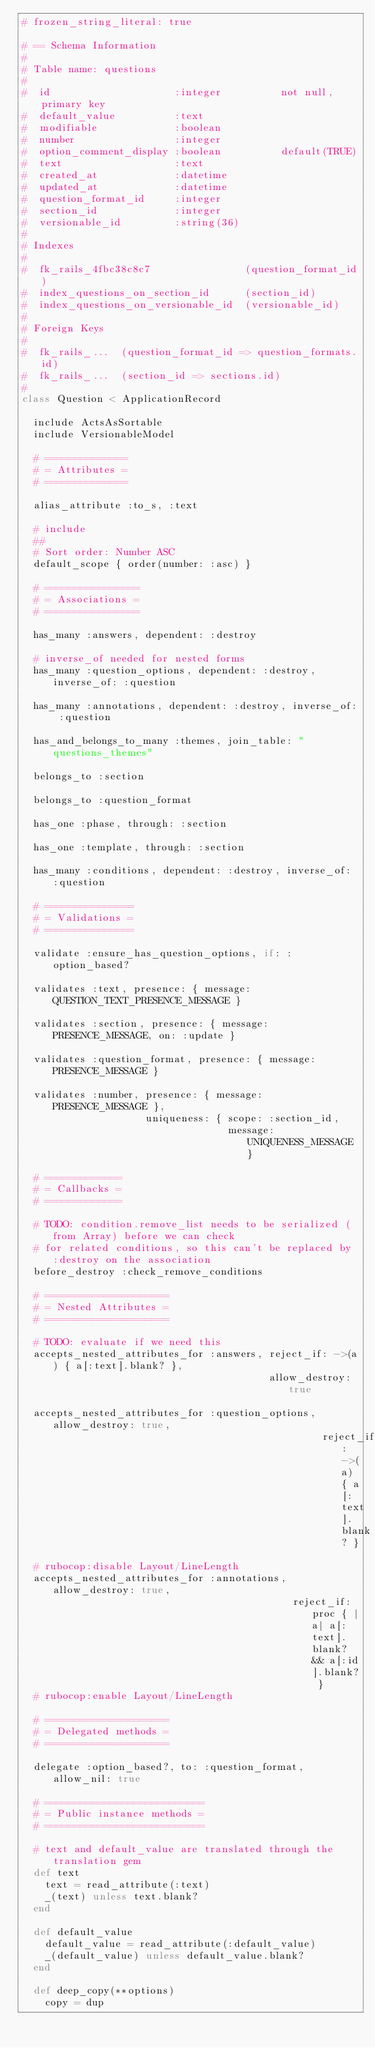Convert code to text. <code><loc_0><loc_0><loc_500><loc_500><_Ruby_># frozen_string_literal: true

# == Schema Information
#
# Table name: questions
#
#  id                     :integer          not null, primary key
#  default_value          :text
#  modifiable             :boolean
#  number                 :integer
#  option_comment_display :boolean          default(TRUE)
#  text                   :text
#  created_at             :datetime
#  updated_at             :datetime
#  question_format_id     :integer
#  section_id             :integer
#  versionable_id         :string(36)
#
# Indexes
#
#  fk_rails_4fbc38c8c7                (question_format_id)
#  index_questions_on_section_id      (section_id)
#  index_questions_on_versionable_id  (versionable_id)
#
# Foreign Keys
#
#  fk_rails_...  (question_format_id => question_formats.id)
#  fk_rails_...  (section_id => sections.id)
#
class Question < ApplicationRecord

  include ActsAsSortable
  include VersionableModel

  # ==============
  # = Attributes =
  # ==============

  alias_attribute :to_s, :text

  # include
  ##
  # Sort order: Number ASC
  default_scope { order(number: :asc) }

  # ================
  # = Associations =
  # ================

  has_many :answers, dependent: :destroy

  # inverse_of needed for nested forms
  has_many :question_options, dependent: :destroy, inverse_of: :question

  has_many :annotations, dependent: :destroy, inverse_of: :question

  has_and_belongs_to_many :themes, join_table: "questions_themes"

  belongs_to :section

  belongs_to :question_format

  has_one :phase, through: :section

  has_one :template, through: :section

  has_many :conditions, dependent: :destroy, inverse_of: :question

  # ===============
  # = Validations =
  # ===============

  validate :ensure_has_question_options, if: :option_based?

  validates :text, presence: { message: QUESTION_TEXT_PRESENCE_MESSAGE }

  validates :section, presence: { message: PRESENCE_MESSAGE, on: :update }

  validates :question_format, presence: { message: PRESENCE_MESSAGE }

  validates :number, presence: { message: PRESENCE_MESSAGE },
                     uniqueness: { scope: :section_id,
                                   message: UNIQUENESS_MESSAGE }

  # =============
  # = Callbacks =
  # =============

  # TODO: condition.remove_list needs to be serialized (from Array) before we can check
  # for related conditions, so this can't be replaced by :destroy on the association
  before_destroy :check_remove_conditions

  # =====================
  # = Nested Attributes =
  # =====================

  # TODO: evaluate if we need this
  accepts_nested_attributes_for :answers, reject_if: ->(a) { a[:text].blank? },
                                          allow_destroy: true

  accepts_nested_attributes_for :question_options, allow_destroy: true,
                                                   reject_if: ->(a) { a[:text].blank? }

  # rubocop:disable Layout/LineLength
  accepts_nested_attributes_for :annotations, allow_destroy: true,
                                              reject_if: proc { |a| a[:text].blank? && a[:id].blank? }
  # rubocop:enable Layout/LineLength

  # =====================
  # = Delegated methods =
  # =====================

  delegate :option_based?, to: :question_format, allow_nil: true

  # ===========================
  # = Public instance methods =
  # ===========================

  # text and default_value are translated through the translation gem
  def text
    text = read_attribute(:text)
    _(text) unless text.blank?
  end

  def default_value
    default_value = read_attribute(:default_value)
    _(default_value) unless default_value.blank?
  end
  
  def deep_copy(**options)
    copy = dup</code> 